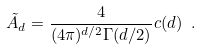<formula> <loc_0><loc_0><loc_500><loc_500>\tilde { A } _ { d } = \frac { 4 } { ( 4 \pi ) ^ { d / 2 } \Gamma ( d / 2 ) } c ( d ) \ .</formula> 